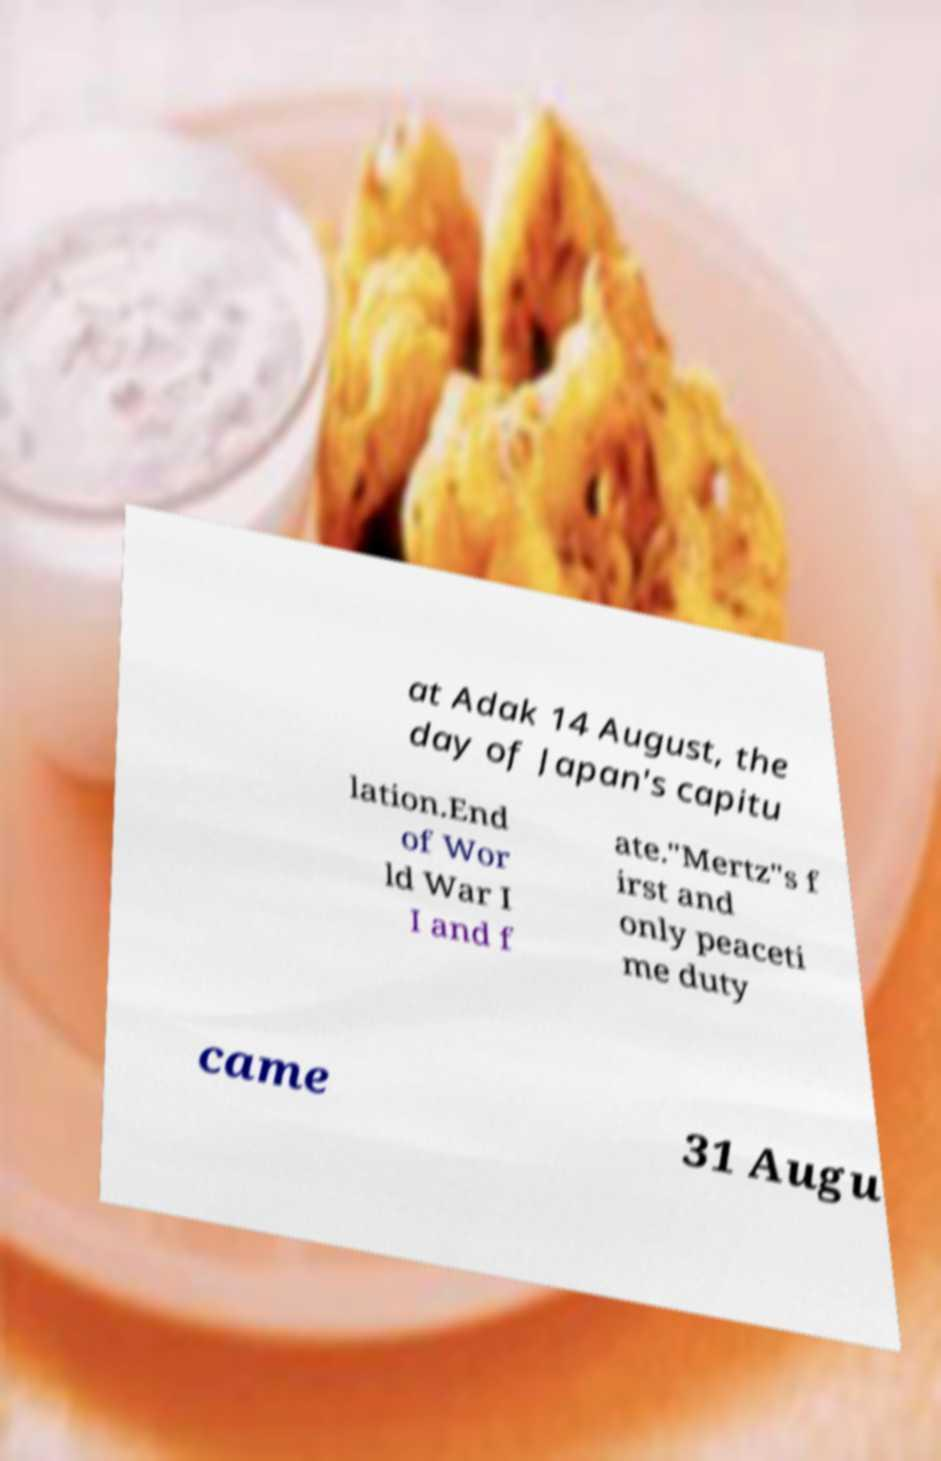Please identify and transcribe the text found in this image. at Adak 14 August, the day of Japan's capitu lation.End of Wor ld War I I and f ate."Mertz"s f irst and only peaceti me duty came 31 Augu 